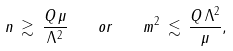<formula> <loc_0><loc_0><loc_500><loc_500>n \, \gtrsim \, \frac { Q \, \mu } { \Lambda ^ { 2 } } \quad o r \quad m ^ { 2 } \, \lesssim \, \frac { Q \, \Lambda ^ { 2 } } { \mu } ,</formula> 